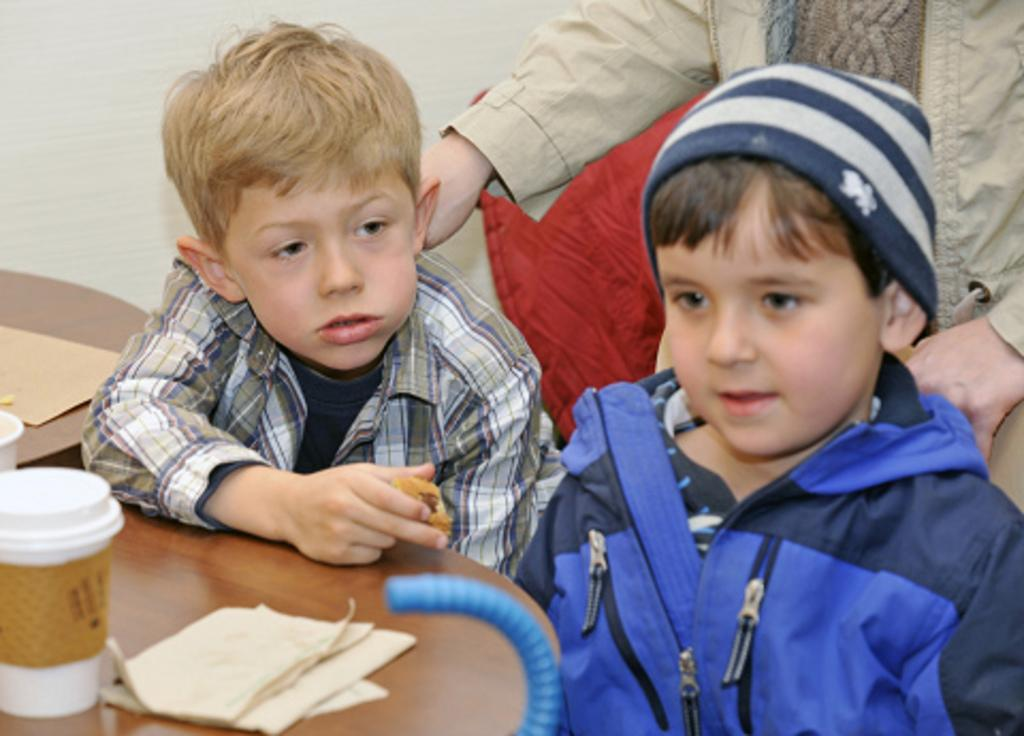How many boys are present in the image? There are two boys in the image. What are the boys doing in the image? The boys are sitting in front of a table. Can you describe the person standing behind the boys? There is a person standing behind the boys, but their appearance or actions are not specified. What can be found on the table in the image? There are objects on the table, but their nature or quantity is not specified. Can you tell me how many boots the giraffe is wearing in the image? There is no giraffe or boots present in the image. 